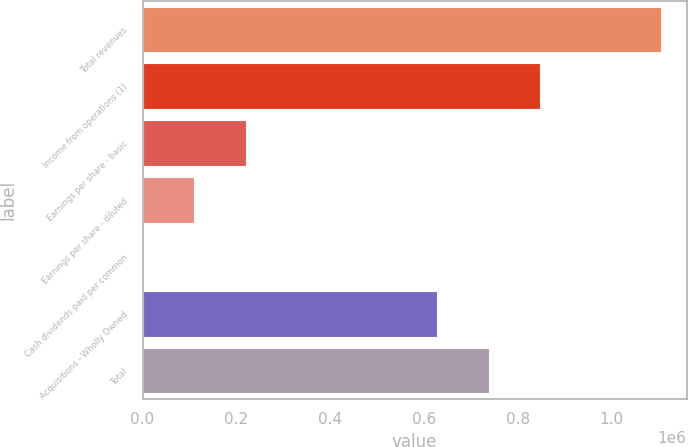<chart> <loc_0><loc_0><loc_500><loc_500><bar_chart><fcel>Total revenues<fcel>Income from operations (1)<fcel>Earnings per share - basic<fcel>Earnings per share - diluted<fcel>Cash dividends paid per common<fcel>Acquisitions - Wholly Owned<fcel>Total<nl><fcel>1.10501e+06<fcel>848463<fcel>221004<fcel>110504<fcel>3.12<fcel>627462<fcel>737963<nl></chart> 